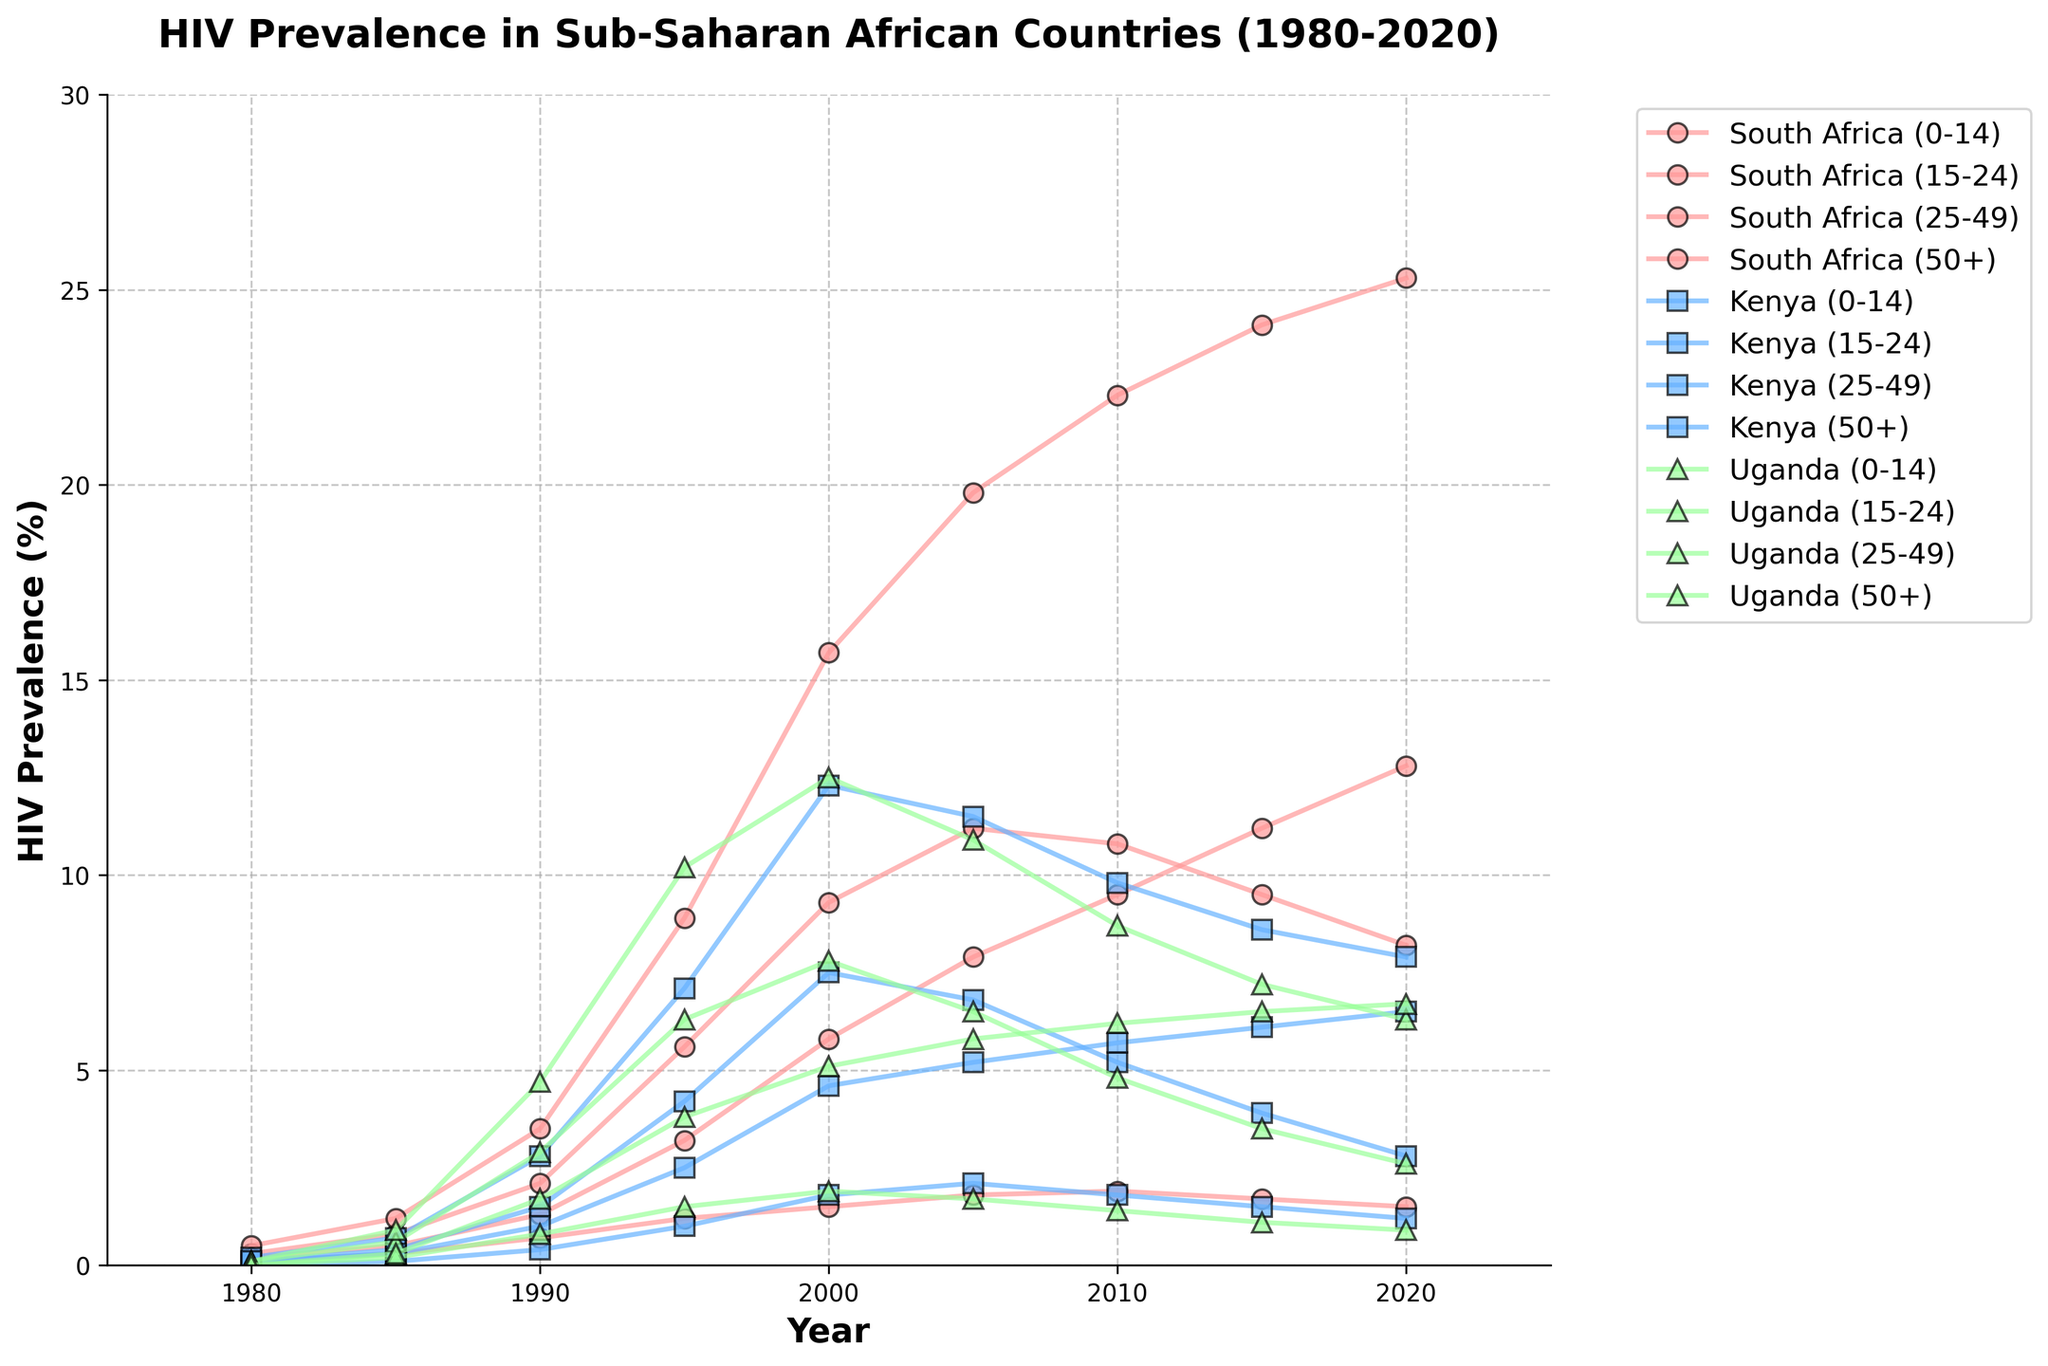Which country had the highest HIV prevalence rate for the age group 25-49 in 2005? To find the answer, look at the 2005 data for the age group 25-49 across all three countries. South Africa has a prevalence rate of 19.8%, Kenya has 11.5%, and Uganda has 10.9%. Thus, South Africa has the highest rate.
Answer: South Africa How did the HIV prevalence rate among the age group 15-24 in Kenya change from 1980 to 2020? To determine the change, observe the HIV prevalence rate for Kenya's 15-24 age group in 1980 (0.1%) and in 2020 (2.8%). The prevalence rate increased from 0.1% to 2.8%.
Answer: Increased by 2.7% Which age group showed the highest increase in HIV prevalence in South Africa from 1980 to 2020? Calculate the difference in prevalence rates from 1980 to 2020 for each age group in South Africa. For age group 0-14: 1.5-0.1=1.4; for 15-24: 8.2-0.3=7.9; for 25-49: 25.3-0.5=24.8; for 50+: 12.8-0.2=12.6. The age group 25-49 shows the highest increase.
Answer: 25-49 Which country had the lowest HIV prevalence rate for age group 50+ in 1985 and 2020? Compare the prevalence rates of the age group 50+ in 1985 and 2020 across South Africa, Kenya, and Uganda. In 1985, Uganda had the lowest rate (0.3%). In 2020, South Africa had the lowest rate (12.8%).
Answer: Uganda (1985), South Africa (2020) Between which years did Uganda's HIV prevalence rate for age group 15-24 peak? Look at the prevalence rate for the 15-24 age group in Uganda from 1980 to 2020. The peak is at 6.3% in 1995.
Answer: Peaked in 1995 In 2015, which country had the highest HIV prevalence rate among the 0-14 age group, and what was the rate? Compare the 2015 HIV prevalence rates for the 0-14 age group across all three countries. South Africa had the highest rate at 1.7%.
Answer: South Africa, 1.7% What is the difference in HIV prevalence rates for the age group 25-49 between Kenya and Uganda in 2000? In 2000, the HIV prevalence rate for age group 25-49 in Kenya was 12.3%, and in Uganda, it was 12.5%. The difference is 12.5% - 12.3% = 0.2%.
Answer: 0.2% What was the average HIV prevalence rate for the age group 0-14 in South Africa from 1980 to 2020? To find the average, sum the prevalence rates for the 0-14 age group in South Africa for the years 1980, 1985, 1990, 1995, 2000, 2005, 2010, 2015, and 2020, and then divide by 9. The rates are 0.1, 0.3, 0.7, 1.2, 1.5, 1.8, 1.9, 1.7, and 1.5. The sum is 10.7 and the average is 10.7/9 ≈ 1.19.
Answer: 1.19 In which year did Kenya have the highest HIV prevalence rate among the 25-49 age group? Find the highest value for Kenya's 25-49 age group from 1980 to 2020. The highest rate is 12.3% in 2000.
Answer: 2000 